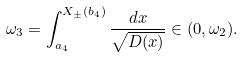<formula> <loc_0><loc_0><loc_500><loc_500>\omega _ { 3 } = \int _ { a _ { 4 } } ^ { X _ { \pm } ( b _ { 4 } ) } \frac { d x } { \sqrt { D ( x ) } } \in ( 0 , \omega _ { 2 } ) .</formula> 